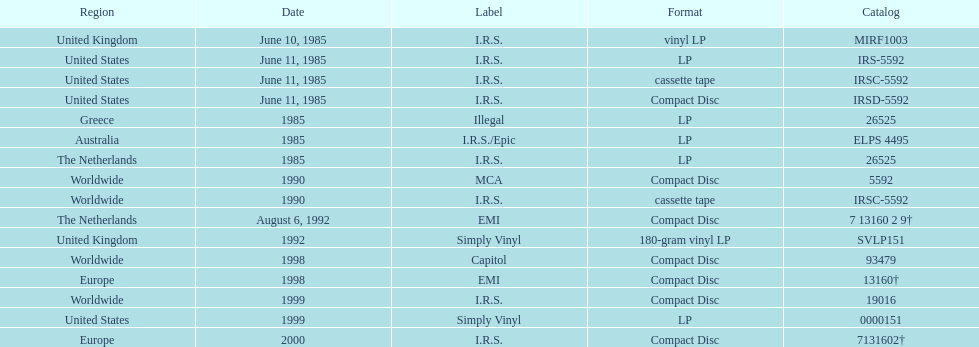What was the date of the first vinyl lp release? June 10, 1985. 